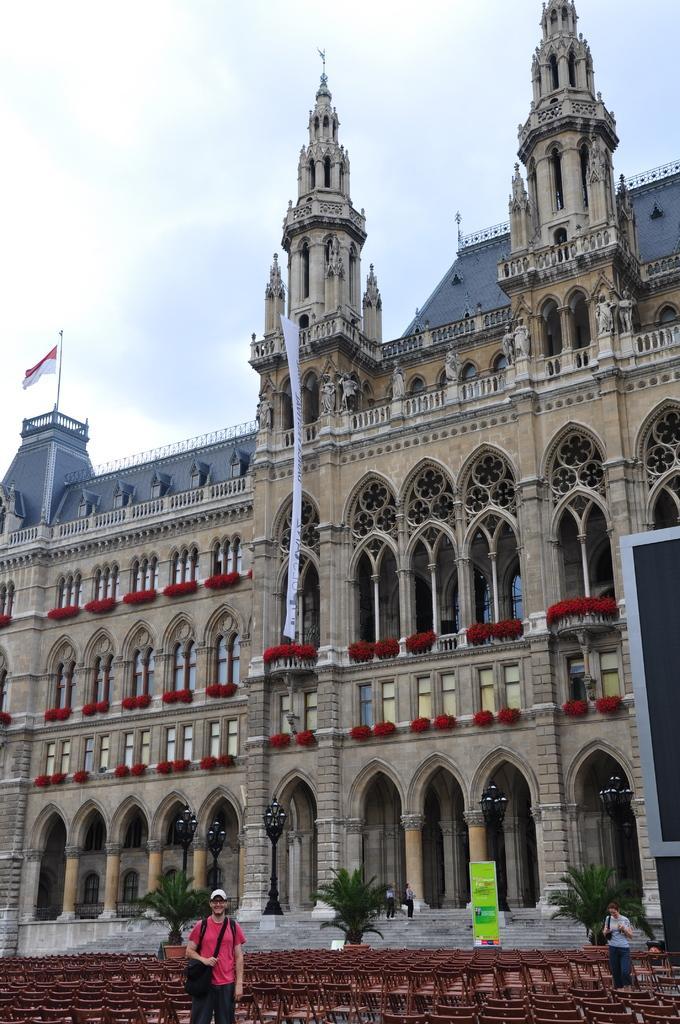How would you summarize this image in a sentence or two? In this picture there is a building and there are flags on the building. In the foreground there are two people standing and there are chairs and there are plants and there is a hoarding and there might be a screen and there are two people standing on the stair case. At the top there is sky and there are clouds. 